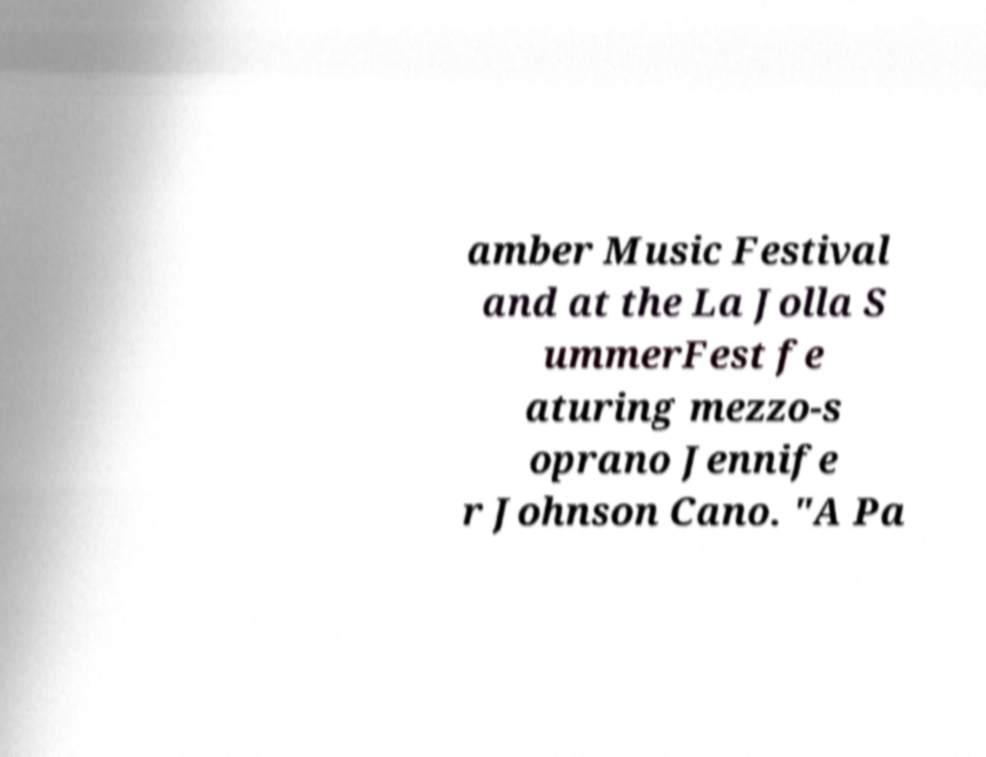Please read and relay the text visible in this image. What does it say? amber Music Festival and at the La Jolla S ummerFest fe aturing mezzo-s oprano Jennife r Johnson Cano. "A Pa 